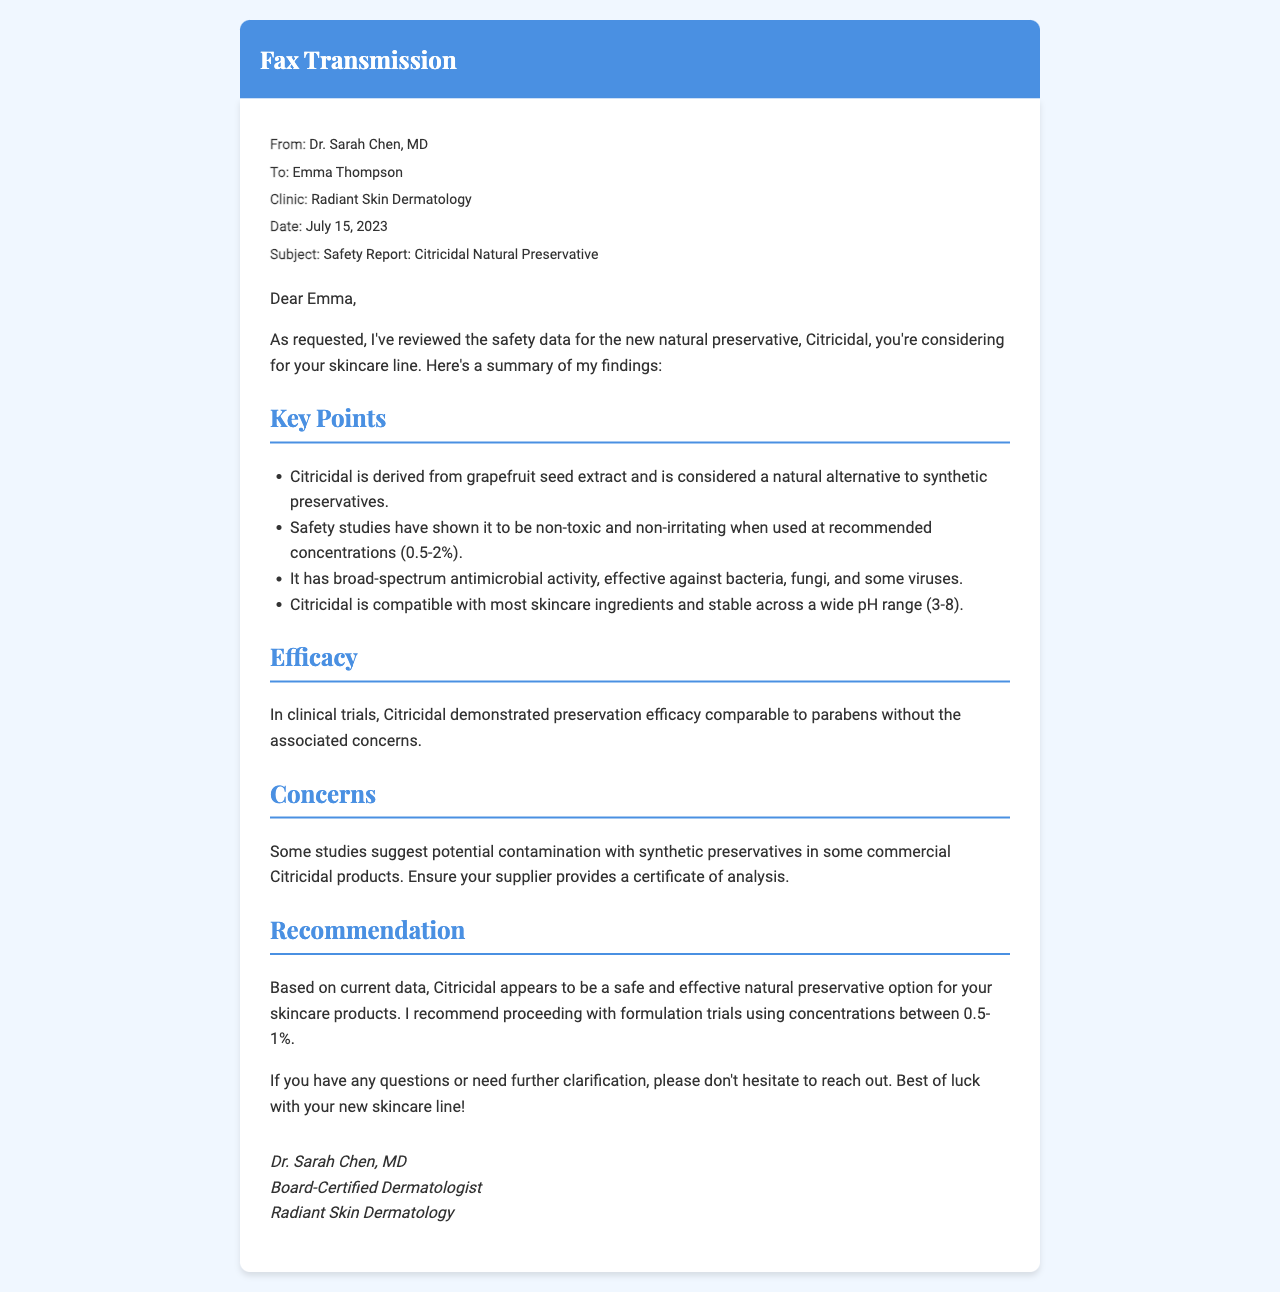What is the subject of the fax? The subject of the fax is indicated in the document and relates to the main topic discussed.
Answer: Safety Report: Citricidal Natural Preservative Who is the sender of the fax? The sender of the fax is mentioned in the document, including their title and professional affiliation.
Answer: Dr. Sarah Chen, MD What is the recommended concentration range for Citricidal? The recommended concentration range is specified in the report, indicating safe levels for use.
Answer: 0.5-2% What kind of activity does Citricidal have? The document states the type of antimicrobial action Citricidal possesses, providing insight into its effectiveness.
Answer: Broad-spectrum antimicrobial activity What potential issue is mentioned regarding some Citricidal products? The fax notes a specific concern regarding the quality of some products, emphasizing the importance of supplier verification.
Answer: Contamination with synthetic preservatives What clinical outcome does Citricidal demonstrate compared to parabens? The outcome is described in a section of the document, highlighting its effectiveness in preservation.
Answer: Comparable preservation efficacy What is the date of the fax? The date is provided at the top of the document, marking when it was sent.
Answer: July 15, 2023 What is Dr. Sarah Chen’s profession? Dr. Chen's profession is noted in the closing section of the fax, affirming her expertise.
Answer: Board-Certified Dermatologist 